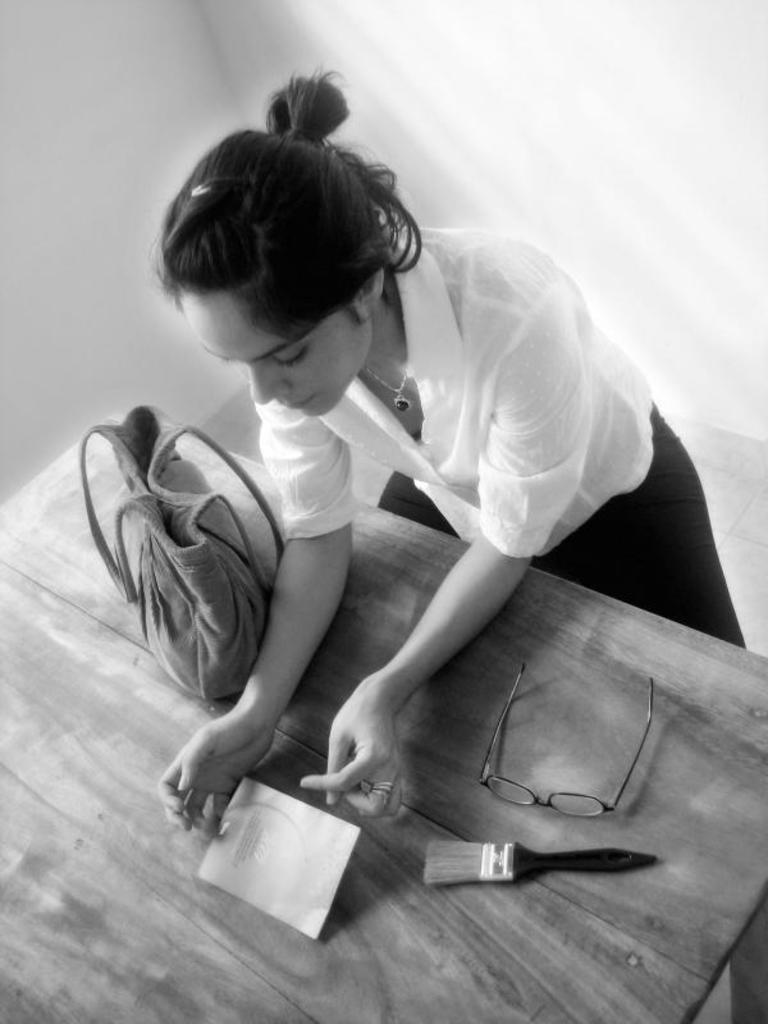What is the color scheme of the image? The image is black and white. What can be seen in the background of the image? There is a person in front of a wall in the image. What is located at the bottom of the image? There is a table at the bottom of the image. What items are present on the table? A bag, spectacles, a brush, and a paper are visible on the table. What type of dog is sitting next to the person in the image? There is no dog present in the image; it is a black and white image with a person in front of a wall, a table at the bottom, and various items on the table. 